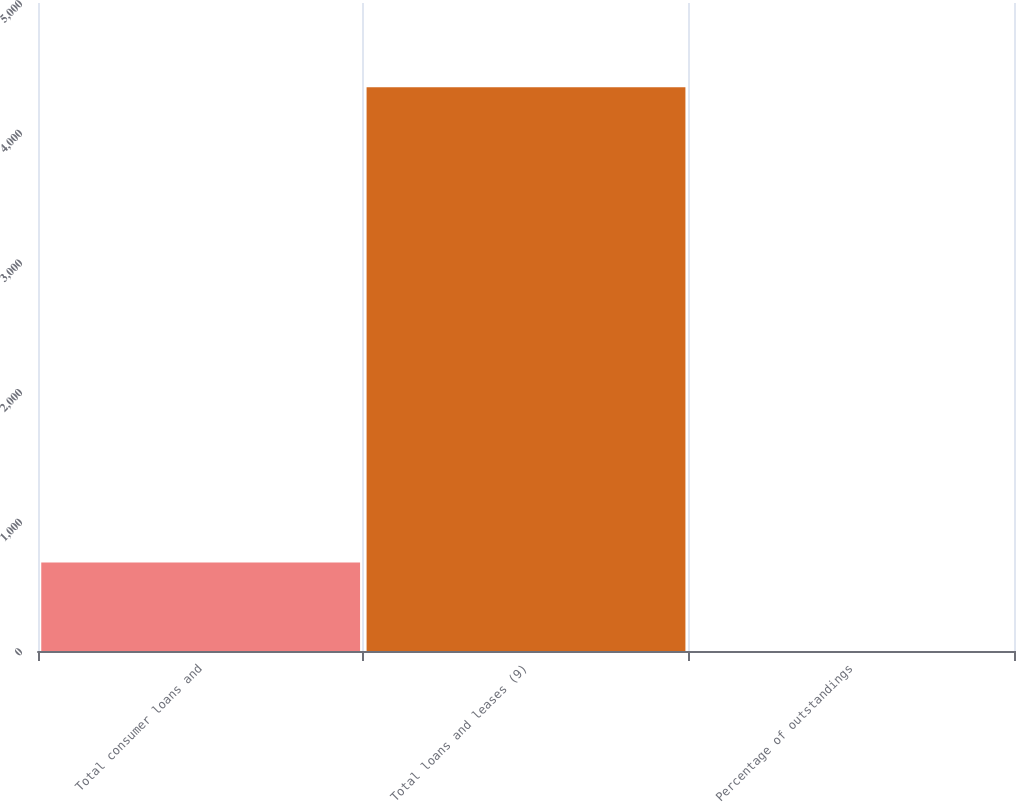Convert chart to OTSL. <chart><loc_0><loc_0><loc_500><loc_500><bar_chart><fcel>Total consumer loans and<fcel>Total loans and leases (9)<fcel>Percentage of outstandings<nl><fcel>682<fcel>4349<fcel>0.46<nl></chart> 